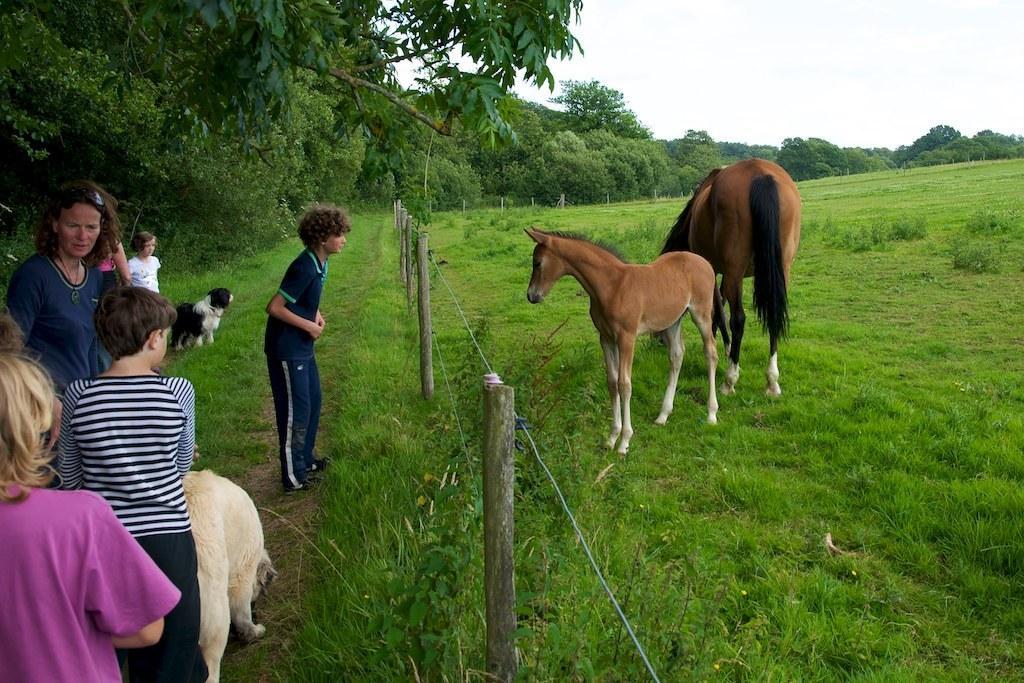Describe this image in one or two sentences. In this image I can see group of people standing, in front the person is wearing pink color shirt. I can also see few animals, they are in brown, cream and black color, and I can see grass and trees in green color, and the sky is in white color. 